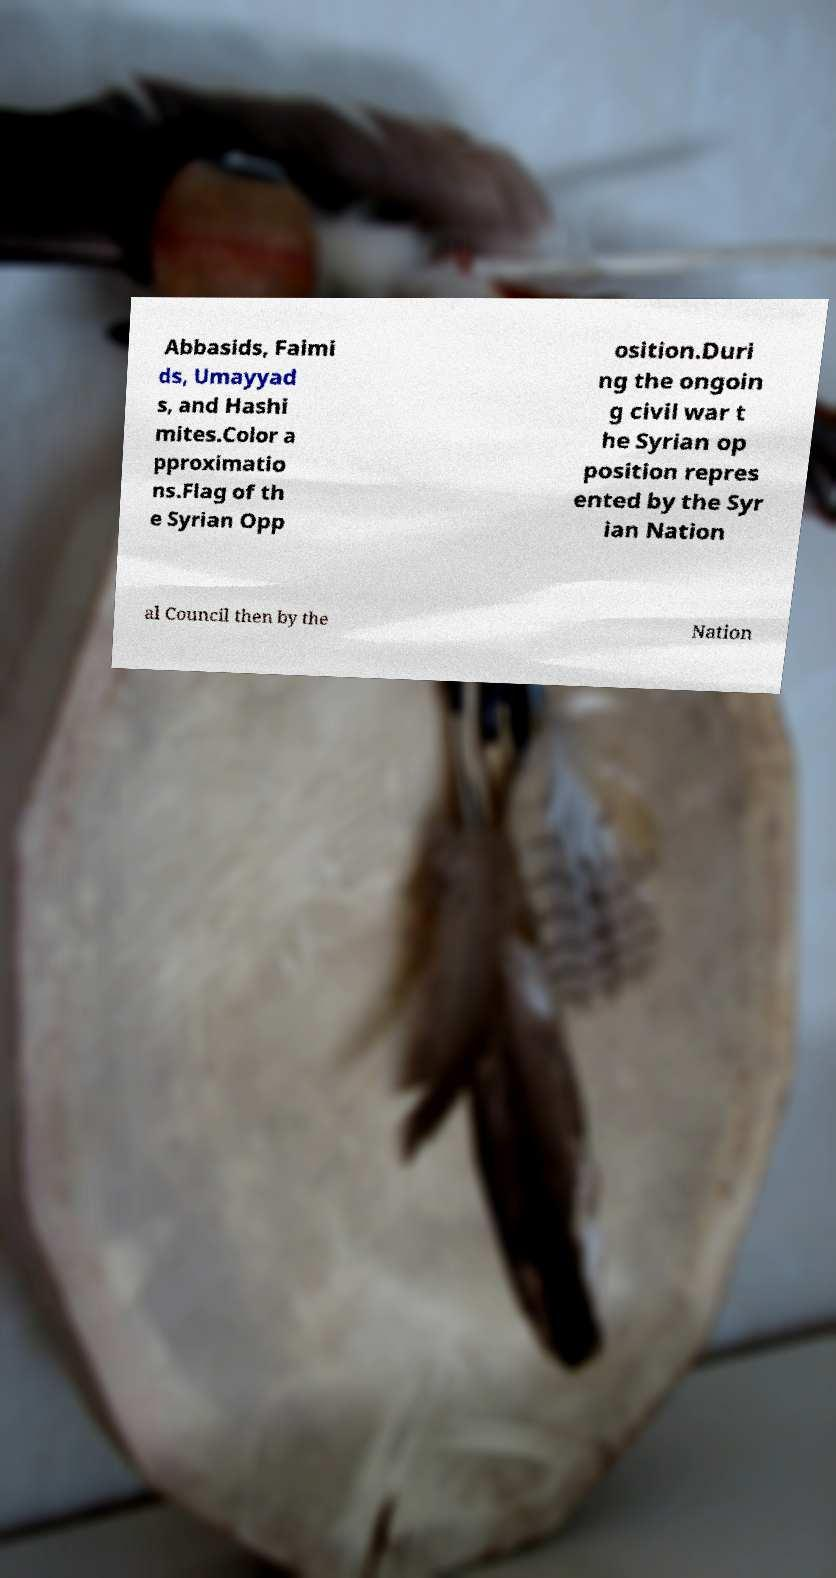Could you assist in decoding the text presented in this image and type it out clearly? Abbasids, Faimi ds, Umayyad s, and Hashi mites.Color a pproximatio ns.Flag of th e Syrian Opp osition.Duri ng the ongoin g civil war t he Syrian op position repres ented by the Syr ian Nation al Council then by the Nation 